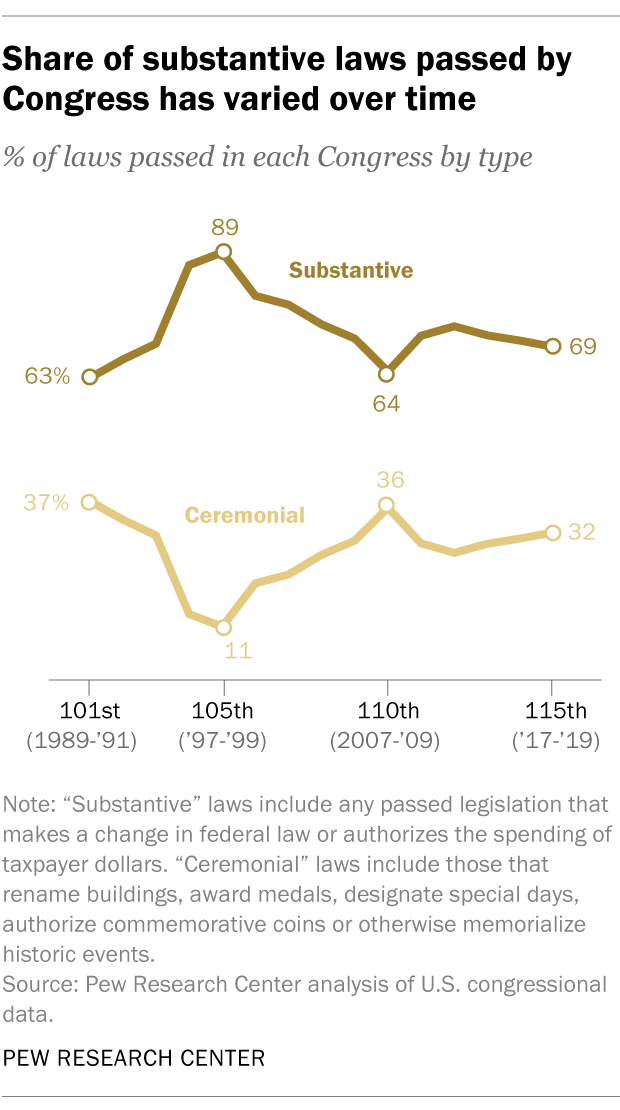Give some essential details in this illustration. The peak values among all the data points are 89. The proportion of substantive laws passed is less than that of ceremonial laws in all years, with no exception. 